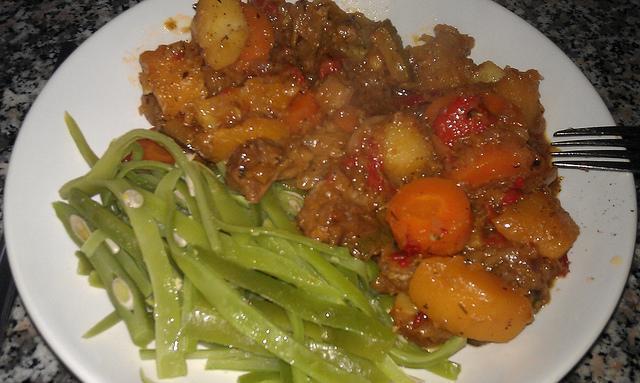How many carrots are visible?
Give a very brief answer. 2. 